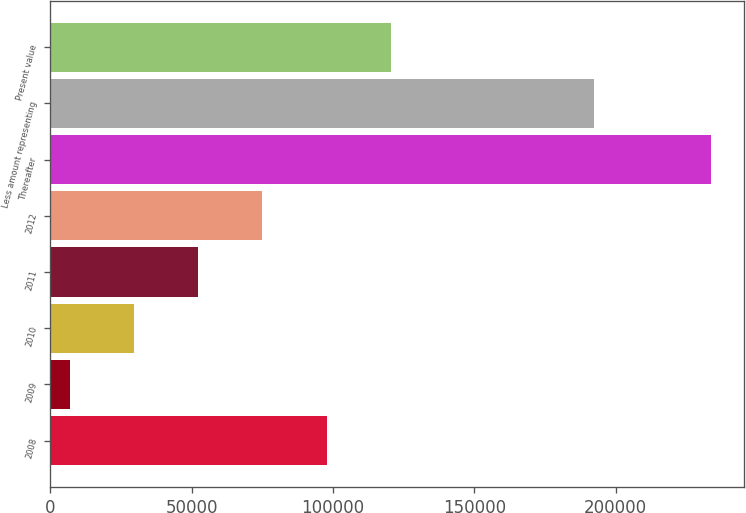Convert chart. <chart><loc_0><loc_0><loc_500><loc_500><bar_chart><fcel>2008<fcel>2009<fcel>2010<fcel>2011<fcel>2012<fcel>Thereafter<fcel>Less amount representing<fcel>Present value<nl><fcel>97725.4<fcel>6905<fcel>29610.1<fcel>52315.2<fcel>75020.3<fcel>233956<fcel>192415<fcel>120430<nl></chart> 